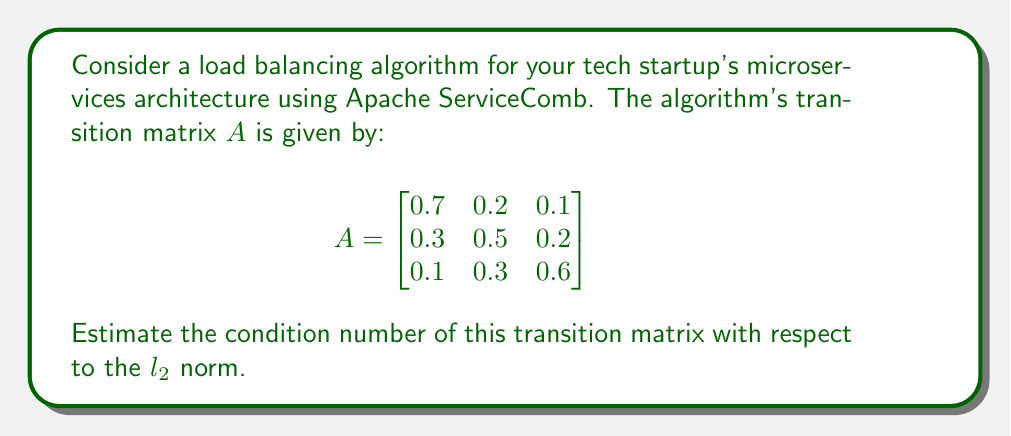Give your solution to this math problem. To estimate the condition number of the transition matrix $A$ with respect to the $l_2$ norm, we follow these steps:

1. The condition number is defined as $\kappa(A) = \|A\| \cdot \|A^{-1}\|$, where $\|\cdot\|$ denotes the matrix norm.

2. For the $l_2$ norm, the condition number is equal to the ratio of the largest to the smallest singular value of $A$:

   $\kappa_2(A) = \frac{\sigma_{\text{max}}(A)}{\sigma_{\text{min}}(A)}$

3. To find the singular values, we need to calculate the eigenvalues of $A^TA$:

   $A^TA = \begin{bmatrix}
   0.59 & 0.31 & 0.19 \\
   0.31 & 0.38 & 0.23 \\
   0.19 & 0.23 & 0.41
   \end{bmatrix}$

4. The characteristic polynomial of $A^TA$ is:
   $p(\lambda) = -\lambda^3 + 1.38\lambda^2 - 0.1891\lambda + 0.0081$

5. Solving this polynomial numerically, we get the eigenvalues:
   $\lambda_1 \approx 1.0597$, $\lambda_2 \approx 0.2896$, $\lambda_3 \approx 0.0307$

6. The singular values of $A$ are the square roots of these eigenvalues:
   $\sigma_1 \approx 1.0294$, $\sigma_2 \approx 0.5382$, $\sigma_3 \approx 0.1752$

7. The condition number is the ratio of the largest to the smallest singular value:
   $\kappa_2(A) \approx \frac{1.0294}{0.1752} \approx 5.8756$

Therefore, the estimated condition number of the transition matrix is approximately 5.8756.
Answer: $\kappa_2(A) \approx 5.8756$ 